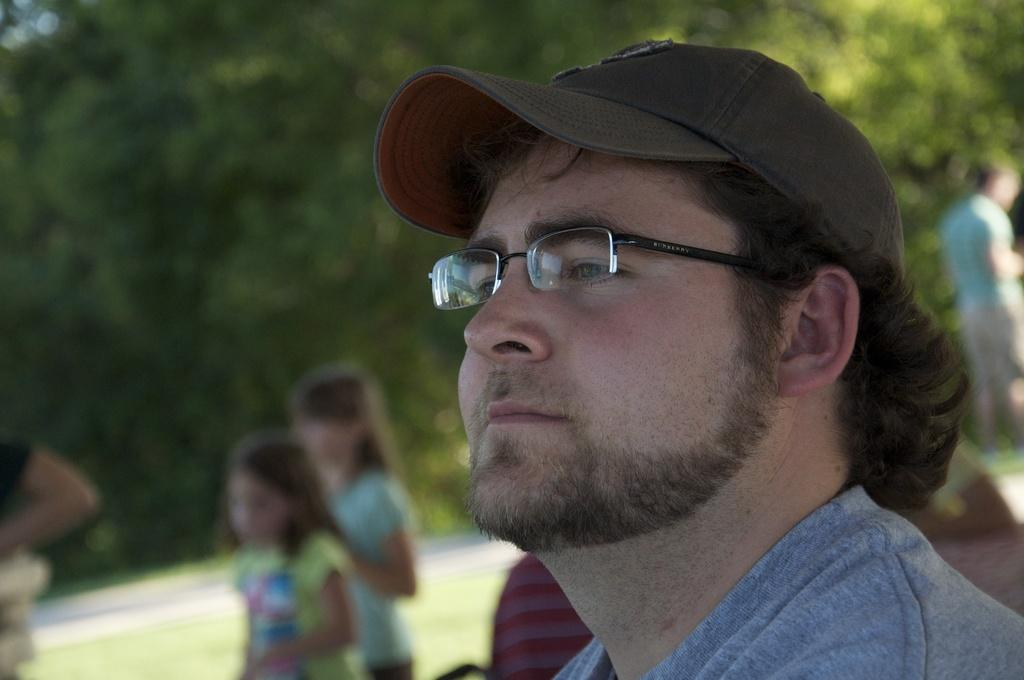Who is the main subject in the image? There is a man in the image. What is the man wearing on his head? The man is wearing a cap. What else is the man wearing? The man is wearing spectacles. Can you describe the other people in the image? There are people in the image, but their specific details are not mentioned in the facts. What type of natural environment is visible in the image? Trees are visible in the image. How would you describe the background of the image? The background of the image is blurred. What type of breakfast is the man eating in the image? There is no mention of breakfast in the image or the provided facts. How does the man show respect to the trees in the image? There is no indication of the man showing respect to the trees in the image or the provided facts. 